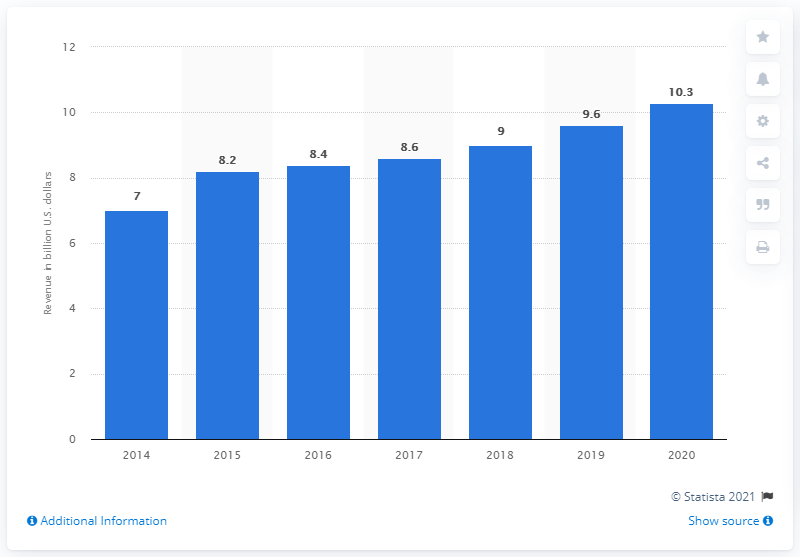List a handful of essential elements in this visual. BDO's total revenue for the fiscal year ending September 30, 2020 was 10.3 million. 